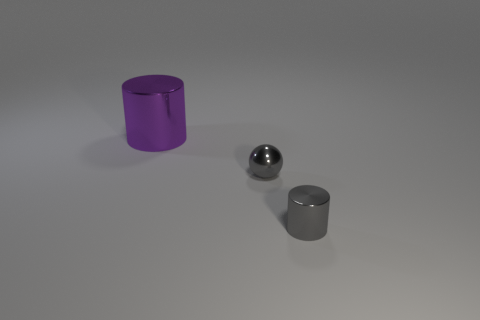The small ball is what color?
Make the answer very short. Gray. Is the color of the cylinder right of the tiny ball the same as the metallic cylinder behind the small gray cylinder?
Give a very brief answer. No. Is there a metal cylinder that has the same color as the tiny sphere?
Provide a succinct answer. Yes. What number of balls have the same color as the large object?
Your response must be concise. 0. What number of things are either gray things that are to the right of the ball or metal cylinders?
Your answer should be compact. 2. What is the color of the small object that is the same material as the tiny ball?
Make the answer very short. Gray. Are there any purple rubber cylinders that have the same size as the purple metallic cylinder?
Keep it short and to the point. No. How many objects are either tiny gray things in front of the gray sphere or things in front of the big purple cylinder?
Provide a succinct answer. 2. There is a thing that is the same size as the gray metallic cylinder; what is its shape?
Offer a terse response. Sphere. Are there any brown matte things that have the same shape as the purple object?
Provide a succinct answer. No. 